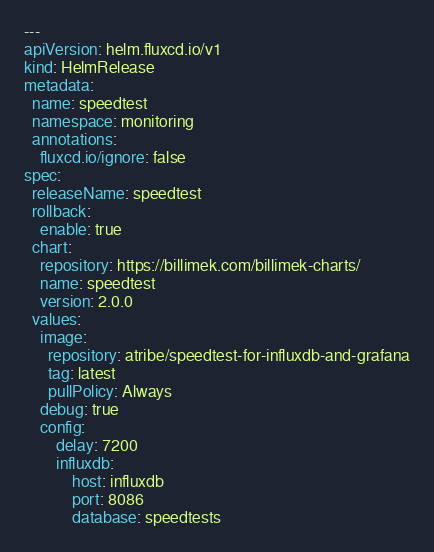<code> <loc_0><loc_0><loc_500><loc_500><_YAML_>---
apiVersion: helm.fluxcd.io/v1
kind: HelmRelease
metadata:
  name: speedtest
  namespace: monitoring
  annotations:
    fluxcd.io/ignore: false
spec:
  releaseName: speedtest
  rollback:
    enable: true
  chart:
    repository: https://billimek.com/billimek-charts/
    name: speedtest
    version: 2.0.0
  values:
    image:
      repository: atribe/speedtest-for-influxdb-and-grafana
      tag: latest
      pullPolicy: Always
    debug: true
    config:
        delay: 7200
        influxdb:
            host: influxdb
            port: 8086
            database: speedtests
</code> 